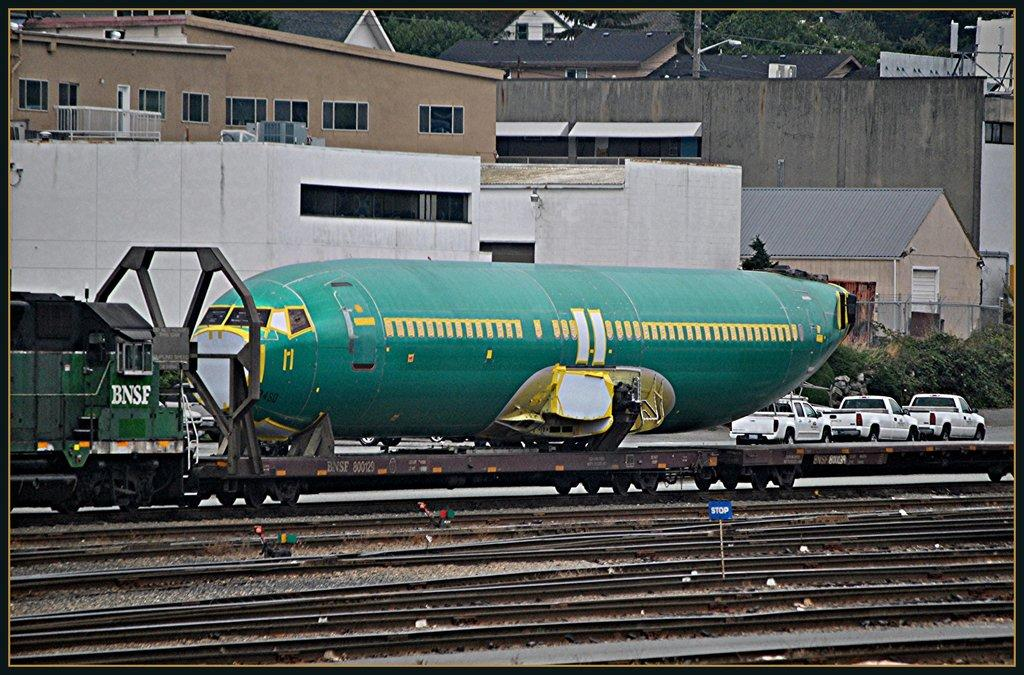Provide a one-sentence caption for the provided image. Train with the letters BNSF on it is transporting something. 